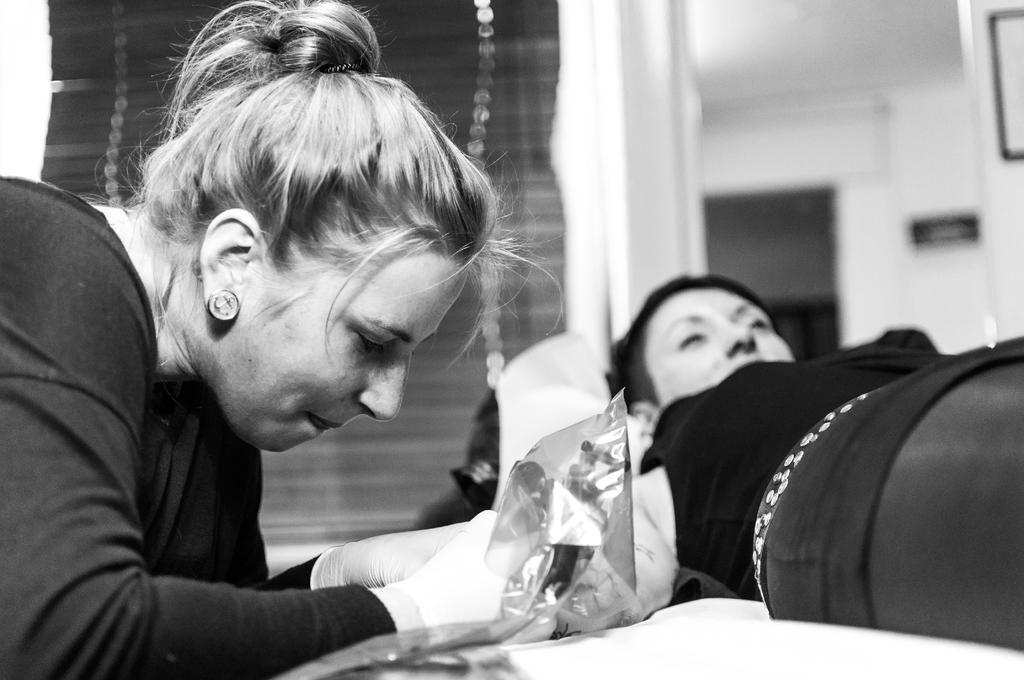What is the person on the right side of the image doing? There is a person lying on the bed on the right side of the image. What is the lady on the left side of the image holding? There is a lady holding an object on the left side of the image. What can be seen in the background of the image? There is a door, a wall, and blinds visible in the background of the image. What type of company is providing the cover for the bed in the image? There is no company mentioned or implied in the image, and no cover for the bed is visible. 